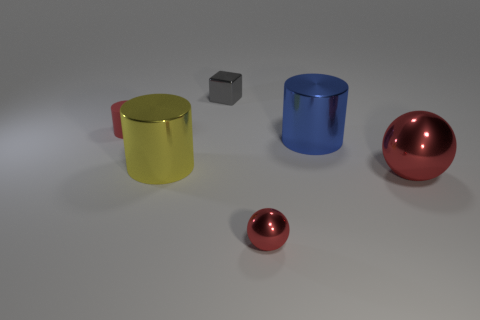Subtract 1 cylinders. How many cylinders are left? 2 Subtract all big blue metal cylinders. How many cylinders are left? 2 Add 2 cylinders. How many objects exist? 8 Subtract all cubes. How many objects are left? 5 Add 5 purple cubes. How many purple cubes exist? 5 Subtract 1 blue cylinders. How many objects are left? 5 Subtract all big blue shiny cylinders. Subtract all cyan metallic cubes. How many objects are left? 5 Add 5 small red matte things. How many small red matte things are left? 6 